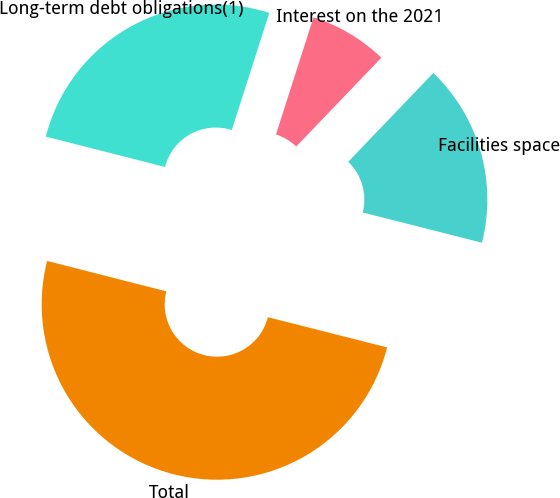Convert chart to OTSL. <chart><loc_0><loc_0><loc_500><loc_500><pie_chart><fcel>Long-term debt obligations(1)<fcel>Interest on the 2021<fcel>Facilities space<fcel>Total<nl><fcel>25.96%<fcel>7.23%<fcel>16.79%<fcel>50.03%<nl></chart> 